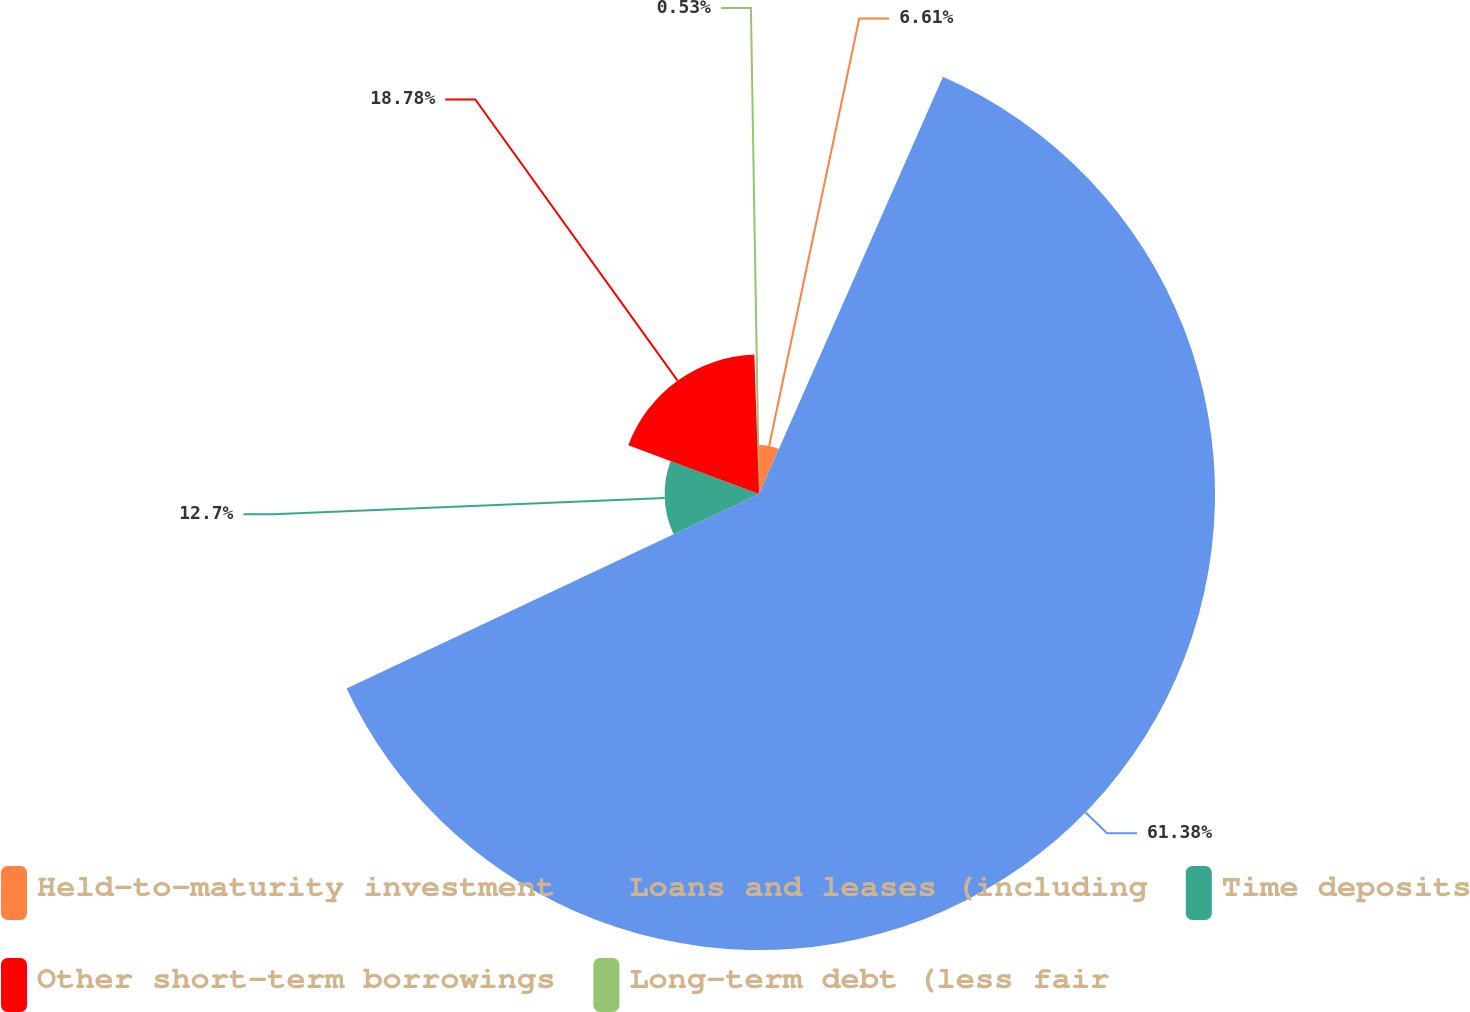Convert chart to OTSL. <chart><loc_0><loc_0><loc_500><loc_500><pie_chart><fcel>Held-to-maturity investment<fcel>Loans and leases (including<fcel>Time deposits<fcel>Other short-term borrowings<fcel>Long-term debt (less fair<nl><fcel>6.61%<fcel>61.37%<fcel>12.7%<fcel>18.78%<fcel>0.53%<nl></chart> 